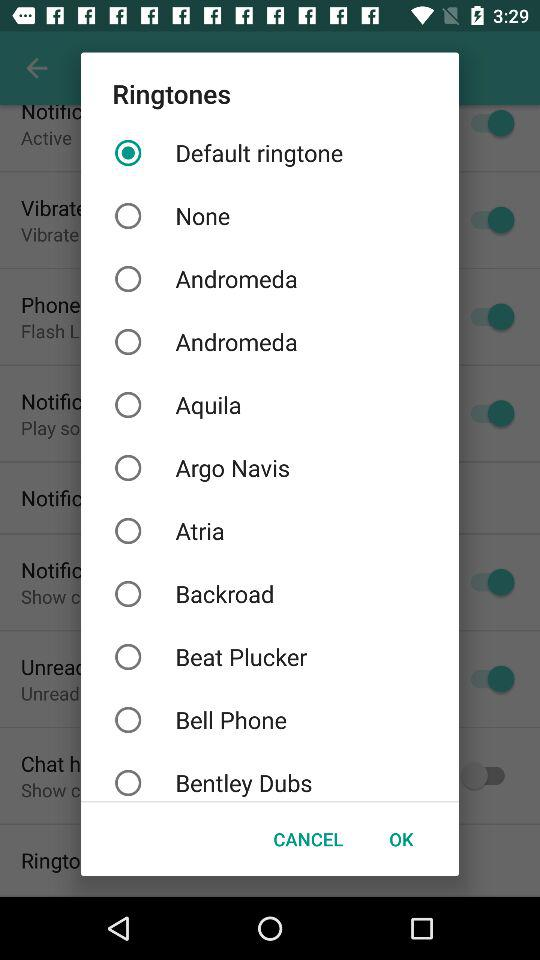How many ringtones are there?
Answer the question using a single word or phrase. 10 